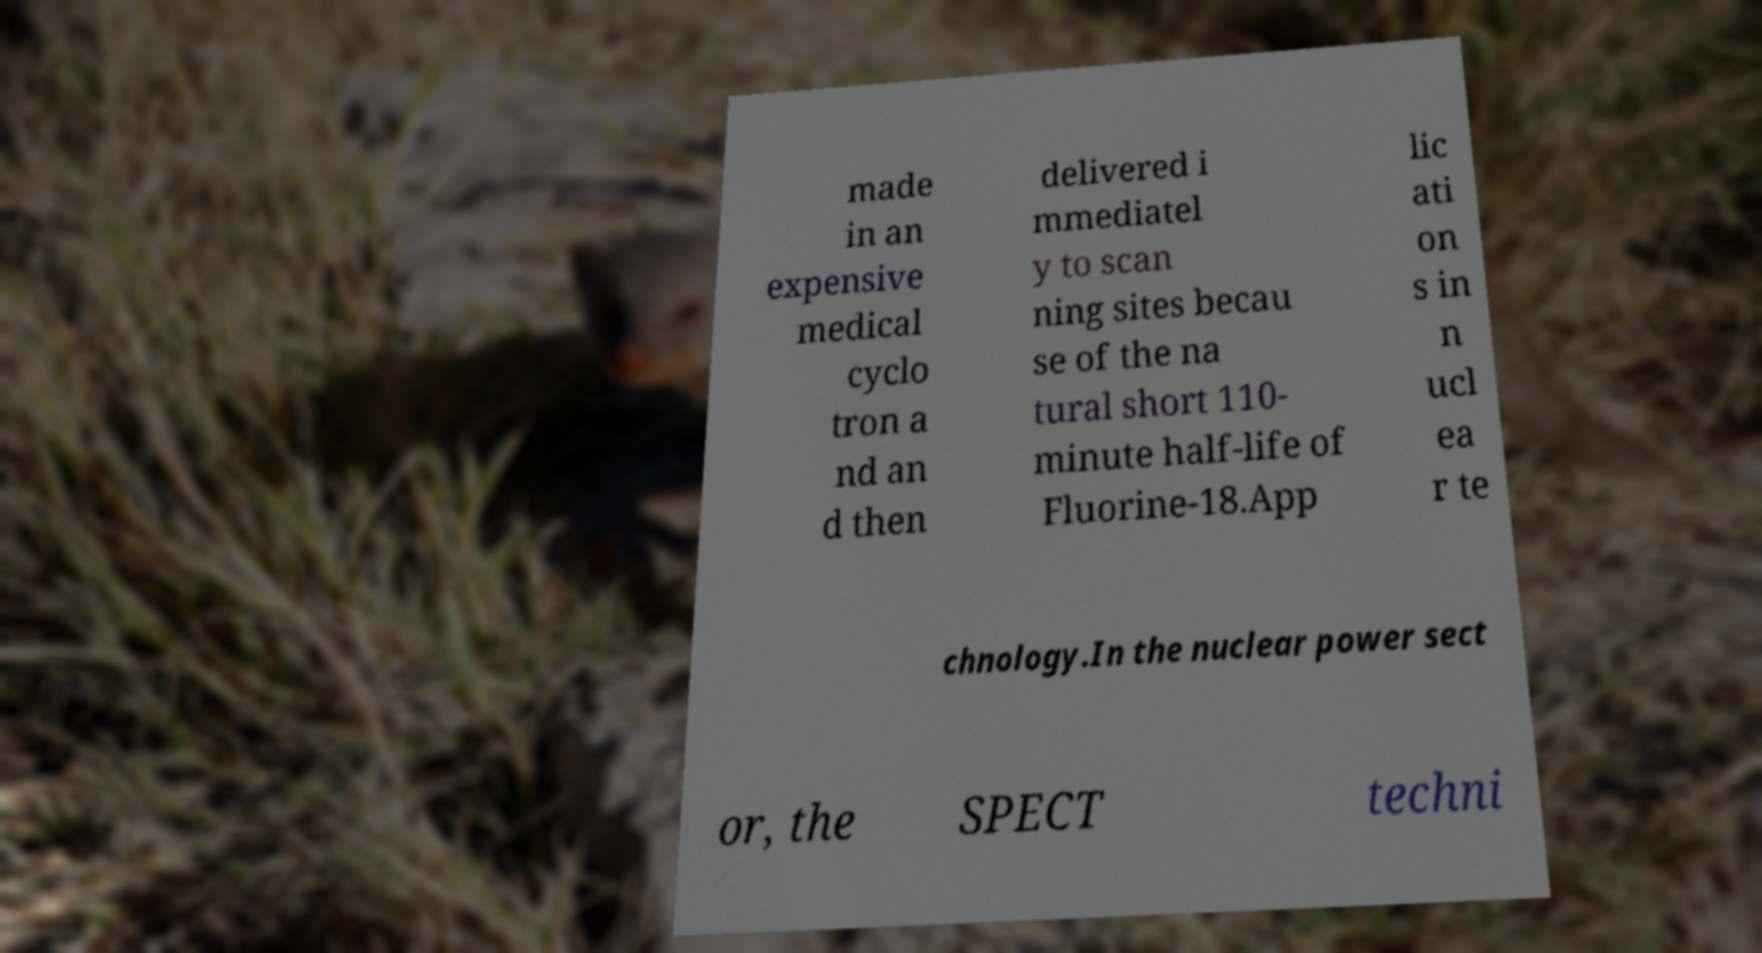There's text embedded in this image that I need extracted. Can you transcribe it verbatim? made in an expensive medical cyclo tron a nd an d then delivered i mmediatel y to scan ning sites becau se of the na tural short 110- minute half-life of Fluorine-18.App lic ati on s in n ucl ea r te chnology.In the nuclear power sect or, the SPECT techni 